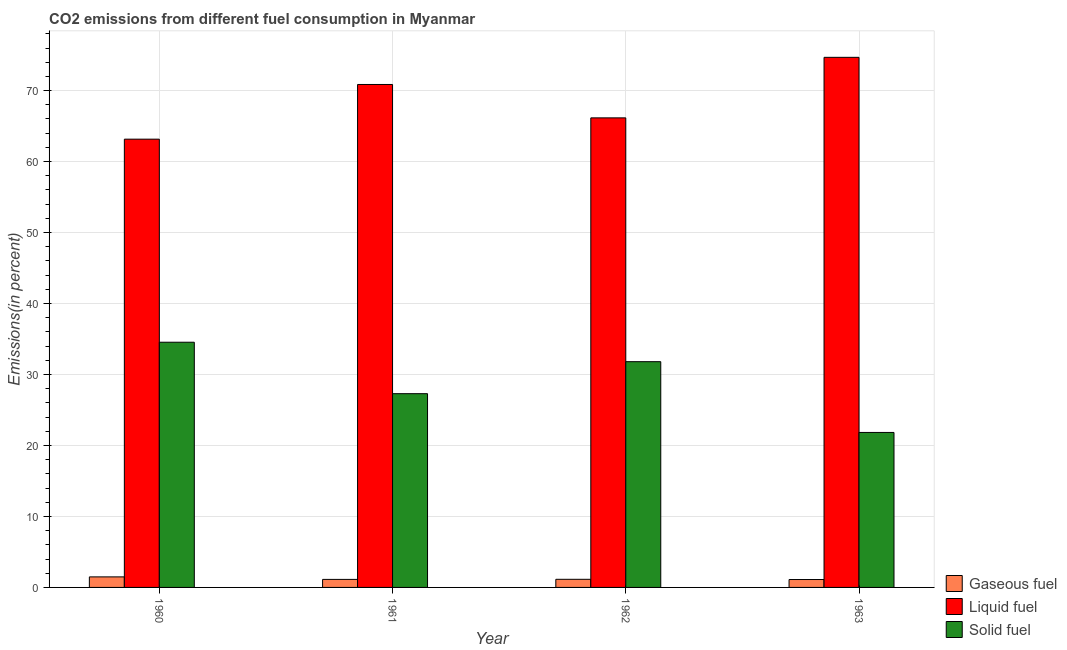Are the number of bars per tick equal to the number of legend labels?
Keep it short and to the point. Yes. Are the number of bars on each tick of the X-axis equal?
Your response must be concise. Yes. In how many cases, is the number of bars for a given year not equal to the number of legend labels?
Provide a succinct answer. 0. What is the percentage of solid fuel emission in 1962?
Ensure brevity in your answer.  31.81. Across all years, what is the maximum percentage of gaseous fuel emission?
Your response must be concise. 1.48. Across all years, what is the minimum percentage of liquid fuel emission?
Make the answer very short. 63.16. In which year was the percentage of gaseous fuel emission minimum?
Offer a terse response. 1963. What is the total percentage of gaseous fuel emission in the graph?
Offer a terse response. 4.87. What is the difference between the percentage of solid fuel emission in 1960 and that in 1962?
Keep it short and to the point. 2.74. What is the difference between the percentage of gaseous fuel emission in 1961 and the percentage of liquid fuel emission in 1960?
Ensure brevity in your answer.  -0.35. What is the average percentage of solid fuel emission per year?
Your answer should be compact. 28.87. In how many years, is the percentage of liquid fuel emission greater than 76 %?
Give a very brief answer. 0. What is the ratio of the percentage of gaseous fuel emission in 1962 to that in 1963?
Provide a short and direct response. 1.03. Is the difference between the percentage of gaseous fuel emission in 1961 and 1962 greater than the difference between the percentage of solid fuel emission in 1961 and 1962?
Your answer should be very brief. No. What is the difference between the highest and the second highest percentage of liquid fuel emission?
Offer a terse response. 3.82. What is the difference between the highest and the lowest percentage of liquid fuel emission?
Ensure brevity in your answer.  11.53. Is the sum of the percentage of gaseous fuel emission in 1961 and 1962 greater than the maximum percentage of liquid fuel emission across all years?
Your answer should be compact. Yes. What does the 3rd bar from the left in 1961 represents?
Offer a terse response. Solid fuel. What does the 3rd bar from the right in 1961 represents?
Keep it short and to the point. Gaseous fuel. Is it the case that in every year, the sum of the percentage of gaseous fuel emission and percentage of liquid fuel emission is greater than the percentage of solid fuel emission?
Provide a succinct answer. Yes. Are all the bars in the graph horizontal?
Your answer should be very brief. No. Are the values on the major ticks of Y-axis written in scientific E-notation?
Make the answer very short. No. Does the graph contain any zero values?
Keep it short and to the point. No. Where does the legend appear in the graph?
Offer a terse response. Bottom right. How many legend labels are there?
Make the answer very short. 3. What is the title of the graph?
Give a very brief answer. CO2 emissions from different fuel consumption in Myanmar. Does "Travel services" appear as one of the legend labels in the graph?
Offer a very short reply. No. What is the label or title of the X-axis?
Keep it short and to the point. Year. What is the label or title of the Y-axis?
Your response must be concise. Emissions(in percent). What is the Emissions(in percent) in Gaseous fuel in 1960?
Ensure brevity in your answer.  1.48. What is the Emissions(in percent) in Liquid fuel in 1960?
Give a very brief answer. 63.16. What is the Emissions(in percent) of Solid fuel in 1960?
Your answer should be very brief. 34.55. What is the Emissions(in percent) in Gaseous fuel in 1961?
Keep it short and to the point. 1.13. What is the Emissions(in percent) in Liquid fuel in 1961?
Offer a very short reply. 70.86. What is the Emissions(in percent) of Solid fuel in 1961?
Ensure brevity in your answer.  27.3. What is the Emissions(in percent) of Gaseous fuel in 1962?
Offer a terse response. 1.15. What is the Emissions(in percent) of Liquid fuel in 1962?
Give a very brief answer. 66.16. What is the Emissions(in percent) of Solid fuel in 1962?
Offer a terse response. 31.81. What is the Emissions(in percent) of Gaseous fuel in 1963?
Give a very brief answer. 1.11. What is the Emissions(in percent) of Liquid fuel in 1963?
Keep it short and to the point. 74.69. What is the Emissions(in percent) in Solid fuel in 1963?
Give a very brief answer. 21.84. Across all years, what is the maximum Emissions(in percent) of Gaseous fuel?
Offer a very short reply. 1.48. Across all years, what is the maximum Emissions(in percent) in Liquid fuel?
Provide a short and direct response. 74.69. Across all years, what is the maximum Emissions(in percent) in Solid fuel?
Your answer should be very brief. 34.55. Across all years, what is the minimum Emissions(in percent) of Gaseous fuel?
Provide a short and direct response. 1.11. Across all years, what is the minimum Emissions(in percent) in Liquid fuel?
Keep it short and to the point. 63.16. Across all years, what is the minimum Emissions(in percent) in Solid fuel?
Make the answer very short. 21.84. What is the total Emissions(in percent) in Gaseous fuel in the graph?
Offer a very short reply. 4.87. What is the total Emissions(in percent) in Liquid fuel in the graph?
Provide a short and direct response. 274.87. What is the total Emissions(in percent) of Solid fuel in the graph?
Your answer should be very brief. 115.49. What is the difference between the Emissions(in percent) in Gaseous fuel in 1960 and that in 1961?
Keep it short and to the point. 0.35. What is the difference between the Emissions(in percent) in Liquid fuel in 1960 and that in 1961?
Keep it short and to the point. -7.7. What is the difference between the Emissions(in percent) of Solid fuel in 1960 and that in 1961?
Offer a very short reply. 7.25. What is the difference between the Emissions(in percent) in Gaseous fuel in 1960 and that in 1962?
Ensure brevity in your answer.  0.34. What is the difference between the Emissions(in percent) of Liquid fuel in 1960 and that in 1962?
Your answer should be compact. -3. What is the difference between the Emissions(in percent) of Solid fuel in 1960 and that in 1962?
Provide a short and direct response. 2.74. What is the difference between the Emissions(in percent) in Gaseous fuel in 1960 and that in 1963?
Provide a succinct answer. 0.37. What is the difference between the Emissions(in percent) of Liquid fuel in 1960 and that in 1963?
Your answer should be compact. -11.53. What is the difference between the Emissions(in percent) in Solid fuel in 1960 and that in 1963?
Provide a succinct answer. 12.71. What is the difference between the Emissions(in percent) of Gaseous fuel in 1961 and that in 1962?
Offer a terse response. -0.01. What is the difference between the Emissions(in percent) of Liquid fuel in 1961 and that in 1962?
Your answer should be compact. 4.71. What is the difference between the Emissions(in percent) in Solid fuel in 1961 and that in 1962?
Your response must be concise. -4.51. What is the difference between the Emissions(in percent) in Gaseous fuel in 1961 and that in 1963?
Make the answer very short. 0.02. What is the difference between the Emissions(in percent) of Liquid fuel in 1961 and that in 1963?
Your answer should be compact. -3.82. What is the difference between the Emissions(in percent) of Solid fuel in 1961 and that in 1963?
Give a very brief answer. 5.46. What is the difference between the Emissions(in percent) of Gaseous fuel in 1962 and that in 1963?
Your response must be concise. 0.03. What is the difference between the Emissions(in percent) in Liquid fuel in 1962 and that in 1963?
Provide a succinct answer. -8.53. What is the difference between the Emissions(in percent) of Solid fuel in 1962 and that in 1963?
Your answer should be compact. 9.97. What is the difference between the Emissions(in percent) in Gaseous fuel in 1960 and the Emissions(in percent) in Liquid fuel in 1961?
Ensure brevity in your answer.  -69.38. What is the difference between the Emissions(in percent) of Gaseous fuel in 1960 and the Emissions(in percent) of Solid fuel in 1961?
Offer a terse response. -25.81. What is the difference between the Emissions(in percent) of Liquid fuel in 1960 and the Emissions(in percent) of Solid fuel in 1961?
Your response must be concise. 35.86. What is the difference between the Emissions(in percent) of Gaseous fuel in 1960 and the Emissions(in percent) of Liquid fuel in 1962?
Provide a succinct answer. -64.67. What is the difference between the Emissions(in percent) of Gaseous fuel in 1960 and the Emissions(in percent) of Solid fuel in 1962?
Offer a terse response. -30.32. What is the difference between the Emissions(in percent) in Liquid fuel in 1960 and the Emissions(in percent) in Solid fuel in 1962?
Provide a succinct answer. 31.35. What is the difference between the Emissions(in percent) of Gaseous fuel in 1960 and the Emissions(in percent) of Liquid fuel in 1963?
Give a very brief answer. -73.2. What is the difference between the Emissions(in percent) of Gaseous fuel in 1960 and the Emissions(in percent) of Solid fuel in 1963?
Give a very brief answer. -20.35. What is the difference between the Emissions(in percent) in Liquid fuel in 1960 and the Emissions(in percent) in Solid fuel in 1963?
Your response must be concise. 41.32. What is the difference between the Emissions(in percent) in Gaseous fuel in 1961 and the Emissions(in percent) in Liquid fuel in 1962?
Offer a very short reply. -65.03. What is the difference between the Emissions(in percent) in Gaseous fuel in 1961 and the Emissions(in percent) in Solid fuel in 1962?
Keep it short and to the point. -30.68. What is the difference between the Emissions(in percent) in Liquid fuel in 1961 and the Emissions(in percent) in Solid fuel in 1962?
Ensure brevity in your answer.  39.06. What is the difference between the Emissions(in percent) in Gaseous fuel in 1961 and the Emissions(in percent) in Liquid fuel in 1963?
Give a very brief answer. -73.56. What is the difference between the Emissions(in percent) in Gaseous fuel in 1961 and the Emissions(in percent) in Solid fuel in 1963?
Your response must be concise. -20.7. What is the difference between the Emissions(in percent) in Liquid fuel in 1961 and the Emissions(in percent) in Solid fuel in 1963?
Give a very brief answer. 49.03. What is the difference between the Emissions(in percent) of Gaseous fuel in 1962 and the Emissions(in percent) of Liquid fuel in 1963?
Make the answer very short. -73.54. What is the difference between the Emissions(in percent) of Gaseous fuel in 1962 and the Emissions(in percent) of Solid fuel in 1963?
Offer a terse response. -20.69. What is the difference between the Emissions(in percent) of Liquid fuel in 1962 and the Emissions(in percent) of Solid fuel in 1963?
Your response must be concise. 44.32. What is the average Emissions(in percent) in Gaseous fuel per year?
Give a very brief answer. 1.22. What is the average Emissions(in percent) in Liquid fuel per year?
Your response must be concise. 68.72. What is the average Emissions(in percent) of Solid fuel per year?
Offer a terse response. 28.87. In the year 1960, what is the difference between the Emissions(in percent) in Gaseous fuel and Emissions(in percent) in Liquid fuel?
Keep it short and to the point. -61.67. In the year 1960, what is the difference between the Emissions(in percent) in Gaseous fuel and Emissions(in percent) in Solid fuel?
Offer a terse response. -33.06. In the year 1960, what is the difference between the Emissions(in percent) of Liquid fuel and Emissions(in percent) of Solid fuel?
Your response must be concise. 28.61. In the year 1961, what is the difference between the Emissions(in percent) in Gaseous fuel and Emissions(in percent) in Liquid fuel?
Your answer should be very brief. -69.73. In the year 1961, what is the difference between the Emissions(in percent) in Gaseous fuel and Emissions(in percent) in Solid fuel?
Provide a short and direct response. -26.17. In the year 1961, what is the difference between the Emissions(in percent) of Liquid fuel and Emissions(in percent) of Solid fuel?
Give a very brief answer. 43.56. In the year 1962, what is the difference between the Emissions(in percent) of Gaseous fuel and Emissions(in percent) of Liquid fuel?
Provide a short and direct response. -65.01. In the year 1962, what is the difference between the Emissions(in percent) in Gaseous fuel and Emissions(in percent) in Solid fuel?
Provide a short and direct response. -30.66. In the year 1962, what is the difference between the Emissions(in percent) in Liquid fuel and Emissions(in percent) in Solid fuel?
Provide a short and direct response. 34.35. In the year 1963, what is the difference between the Emissions(in percent) in Gaseous fuel and Emissions(in percent) in Liquid fuel?
Make the answer very short. -73.57. In the year 1963, what is the difference between the Emissions(in percent) of Gaseous fuel and Emissions(in percent) of Solid fuel?
Provide a short and direct response. -20.72. In the year 1963, what is the difference between the Emissions(in percent) in Liquid fuel and Emissions(in percent) in Solid fuel?
Give a very brief answer. 52.85. What is the ratio of the Emissions(in percent) in Gaseous fuel in 1960 to that in 1961?
Offer a terse response. 1.31. What is the ratio of the Emissions(in percent) of Liquid fuel in 1960 to that in 1961?
Your answer should be very brief. 0.89. What is the ratio of the Emissions(in percent) of Solid fuel in 1960 to that in 1961?
Your response must be concise. 1.27. What is the ratio of the Emissions(in percent) in Gaseous fuel in 1960 to that in 1962?
Provide a short and direct response. 1.3. What is the ratio of the Emissions(in percent) in Liquid fuel in 1960 to that in 1962?
Your response must be concise. 0.95. What is the ratio of the Emissions(in percent) of Solid fuel in 1960 to that in 1962?
Your response must be concise. 1.09. What is the ratio of the Emissions(in percent) of Gaseous fuel in 1960 to that in 1963?
Give a very brief answer. 1.33. What is the ratio of the Emissions(in percent) in Liquid fuel in 1960 to that in 1963?
Ensure brevity in your answer.  0.85. What is the ratio of the Emissions(in percent) of Solid fuel in 1960 to that in 1963?
Your answer should be very brief. 1.58. What is the ratio of the Emissions(in percent) in Gaseous fuel in 1961 to that in 1962?
Offer a terse response. 0.99. What is the ratio of the Emissions(in percent) in Liquid fuel in 1961 to that in 1962?
Offer a terse response. 1.07. What is the ratio of the Emissions(in percent) in Solid fuel in 1961 to that in 1962?
Give a very brief answer. 0.86. What is the ratio of the Emissions(in percent) in Gaseous fuel in 1961 to that in 1963?
Offer a very short reply. 1.02. What is the ratio of the Emissions(in percent) of Liquid fuel in 1961 to that in 1963?
Make the answer very short. 0.95. What is the ratio of the Emissions(in percent) of Solid fuel in 1961 to that in 1963?
Your response must be concise. 1.25. What is the ratio of the Emissions(in percent) in Gaseous fuel in 1962 to that in 1963?
Your answer should be very brief. 1.03. What is the ratio of the Emissions(in percent) in Liquid fuel in 1962 to that in 1963?
Provide a short and direct response. 0.89. What is the ratio of the Emissions(in percent) of Solid fuel in 1962 to that in 1963?
Offer a very short reply. 1.46. What is the difference between the highest and the second highest Emissions(in percent) of Gaseous fuel?
Give a very brief answer. 0.34. What is the difference between the highest and the second highest Emissions(in percent) in Liquid fuel?
Provide a short and direct response. 3.82. What is the difference between the highest and the second highest Emissions(in percent) of Solid fuel?
Give a very brief answer. 2.74. What is the difference between the highest and the lowest Emissions(in percent) of Gaseous fuel?
Your answer should be very brief. 0.37. What is the difference between the highest and the lowest Emissions(in percent) in Liquid fuel?
Keep it short and to the point. 11.53. What is the difference between the highest and the lowest Emissions(in percent) in Solid fuel?
Provide a succinct answer. 12.71. 